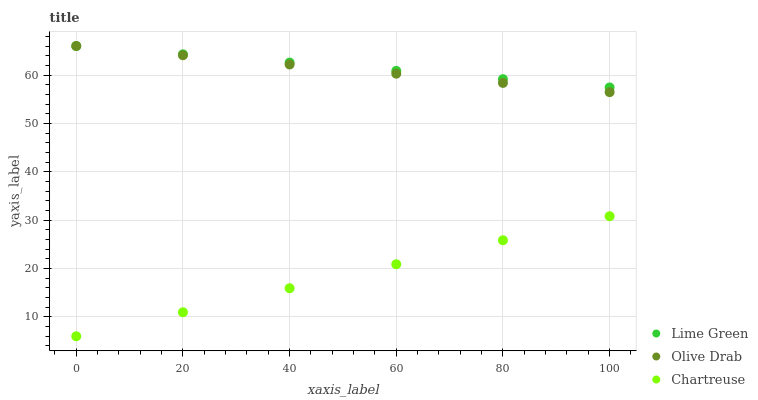Does Chartreuse have the minimum area under the curve?
Answer yes or no. Yes. Does Lime Green have the maximum area under the curve?
Answer yes or no. Yes. Does Olive Drab have the minimum area under the curve?
Answer yes or no. No. Does Olive Drab have the maximum area under the curve?
Answer yes or no. No. Is Chartreuse the smoothest?
Answer yes or no. Yes. Is Olive Drab the roughest?
Answer yes or no. Yes. Is Lime Green the smoothest?
Answer yes or no. No. Is Lime Green the roughest?
Answer yes or no. No. Does Chartreuse have the lowest value?
Answer yes or no. Yes. Does Olive Drab have the lowest value?
Answer yes or no. No. Does Olive Drab have the highest value?
Answer yes or no. Yes. Is Chartreuse less than Lime Green?
Answer yes or no. Yes. Is Lime Green greater than Chartreuse?
Answer yes or no. Yes. Does Olive Drab intersect Lime Green?
Answer yes or no. Yes. Is Olive Drab less than Lime Green?
Answer yes or no. No. Is Olive Drab greater than Lime Green?
Answer yes or no. No. Does Chartreuse intersect Lime Green?
Answer yes or no. No. 